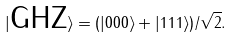Convert formula to latex. <formula><loc_0><loc_0><loc_500><loc_500>| \text {GHZ} \rangle = ( | 0 0 0 \rangle + | 1 1 1 \rangle ) / \sqrt { 2 } .</formula> 